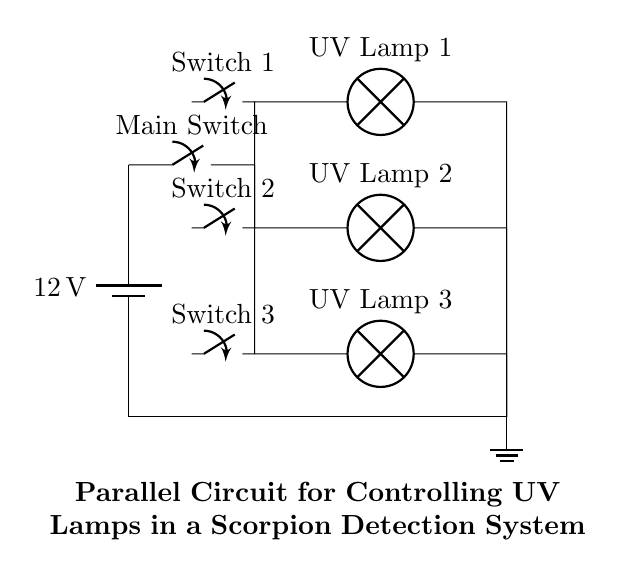What is the voltage supplied to the circuit? The voltage is sourced from a battery marked as 12V. This is evident from the battery component at the beginning of the circuit diagram.
Answer: 12 volts How many UV lamps are used in this circuit? There are three UV lamps present in the diagram, each identified by labels next to lamp symbols. The lamps are situated in separate parallel branches of the circuit.
Answer: Three What is controlling each UV lamp in the circuit? Each UV lamp has an associated switch that controls whether the lamp is on or off. This is visible where each lamp branch connects to a switch just before it joins the power line.
Answer: Switches What is the configuration of the circuit? The circuit is arranged in a parallel configuration, as indicated by multiple branches parallel to each other connected to the same voltage source. This allows each lamp to operate independently.
Answer: Parallel What happens if one UV lamp burns out? If one UV lamp burns out the other lamps will continue to operate, as each branch functions independently due to the parallel arrangement. This is a key characteristic of parallel circuits.
Answer: Others continue What is the purpose of the main switch? The main switch allows the user to control the entire circuit by turning all lamps on or off simultaneously. When in the off position, no current flows to any of the lamps.
Answer: Control Which component is at the bottom of the circuit diagram? The ground symbol is depicted at the bottom of the circuit, indicating the reference point for the circuit potential where all current returns. It connects the circuit to ground for safety and functionality.
Answer: Ground 